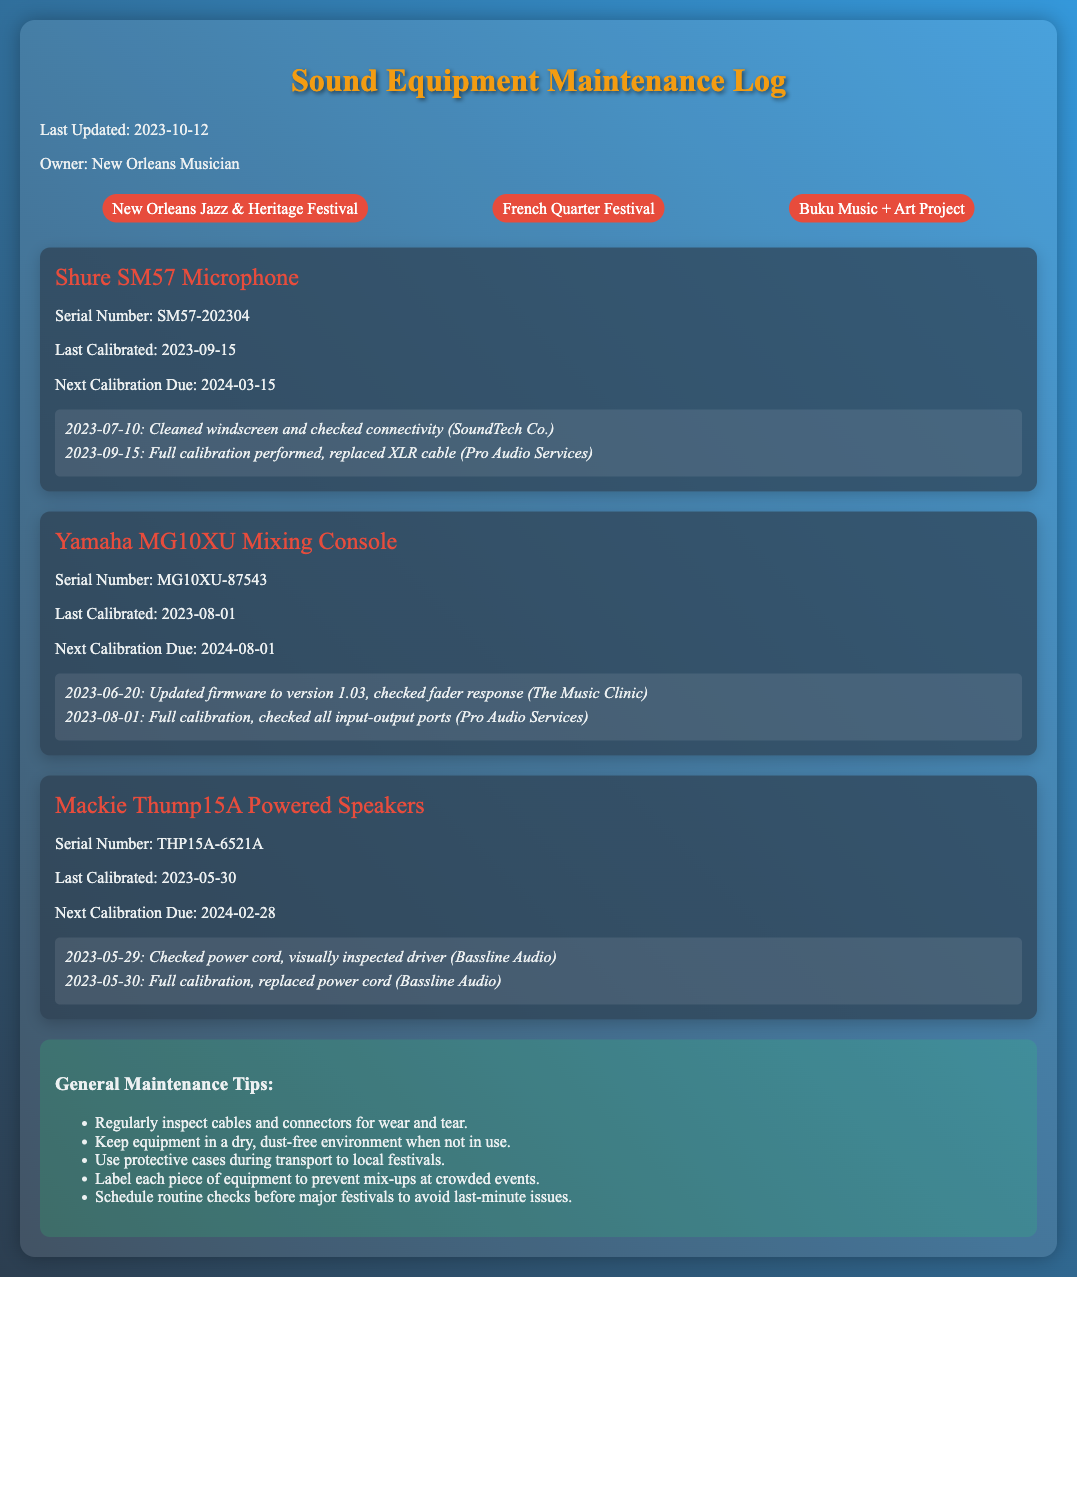What is the last updated date of the document? The last updated date is mentioned at the top of the document as the most recent revision date.
Answer: 2023-10-12 What is the model of the microphone listed in the log? The microphone model is specified in the equipment name section of the log.
Answer: Shure SM57 Microphone When is the next calibration due for the Yamaha MG10XU Mixing Console? The next calibration date is provided directly after the calibration information for the equipment.
Answer: 2024-08-01 How many festivals are listed in the document? The number of festivals is indicated in the festival list section and can be counted from the entries provided.
Answer: 3 What maintenance action was performed on the Shure SM57 Microphone on September 15, 2023? The log specifies the maintenance tasks done on that date under the relevant equipment section.
Answer: Full calibration performed, replaced XLR cable Which company performed the full calibration for the Mackie Thump15A Powered Speakers on May 30, 2023? The maintenance log details the companies involved with the specific equipment checks and calibrations.
Answer: Bassline Audio What is one general maintenance tip mentioned in the document? The tips section includes a list of maintenance suggestions that can be referenced for care and upkeep.
Answer: Regularly inspect cables and connectors for wear and tear How often should routine checks be scheduled before major festivals? The document implies a frequency of routine checks to ensure all equipment is in good condition for events, although it does not specify the exact timing.
Answer: Routine checks should be scheduled before major festivals 